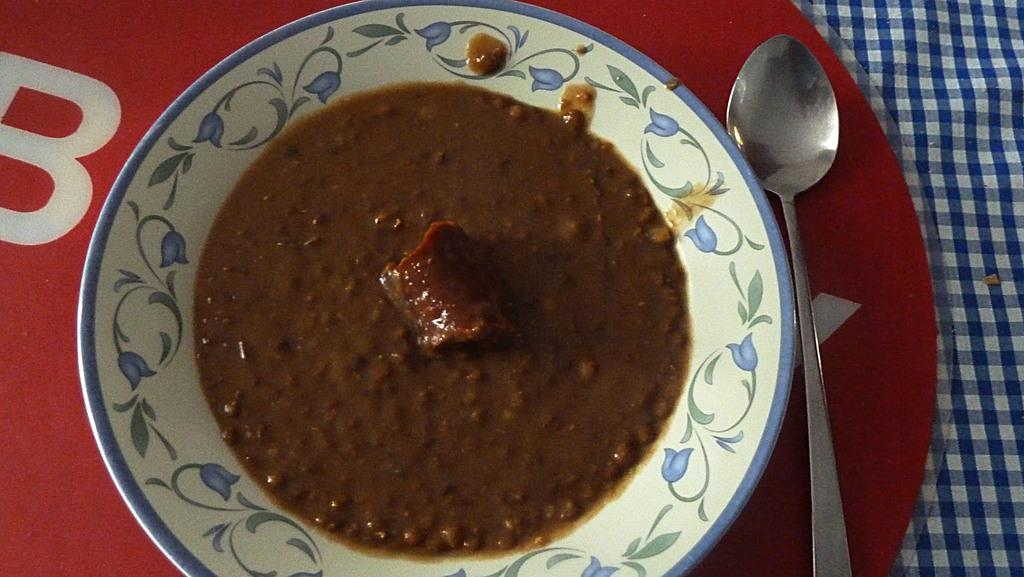What is the main object in the center of the image? There is a plate in the center of the image. What is on the plate? There is food on the plate. What utensil is placed beside the plate? There is a spoon beside the plate. What is under the plate? There is a plastic object and a cloth under the plate. Reasoning: Let's think step by step by breaking down the image into its main components. We start with the plate, which is the central object in the image. Then, we describe what is on the plate, which is food. Next, we identify the utensil, which is a spoon. Finally, we mention the two objects under the plate, which are a plastic object and a cloth. Each question is designed to elicit a specific detail about the image that is known from the provided facts. Absurd Question/Answer: What type of insurance policy is being discussed in the image? There is no mention of insurance in the image; it features a plate with food, a spoon, and objects underneath the plate. What type of blood is visible on the cloth under the plate in the image? There is no blood visible on the cloth under the plate in the image. 